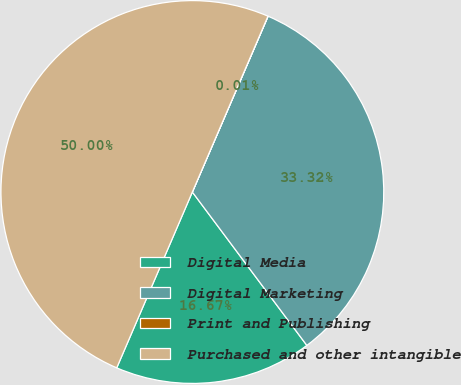Convert chart. <chart><loc_0><loc_0><loc_500><loc_500><pie_chart><fcel>Digital Media<fcel>Digital Marketing<fcel>Print and Publishing<fcel>Purchased and other intangible<nl><fcel>16.67%<fcel>33.32%<fcel>0.01%<fcel>50.0%<nl></chart> 